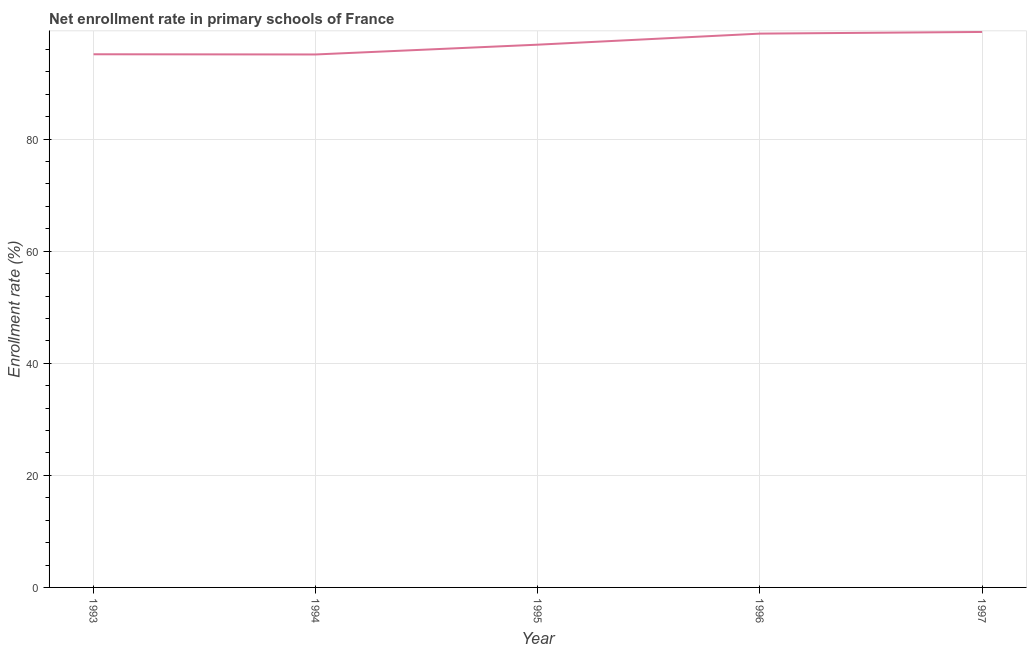What is the net enrollment rate in primary schools in 1997?
Provide a succinct answer. 99.12. Across all years, what is the maximum net enrollment rate in primary schools?
Give a very brief answer. 99.12. Across all years, what is the minimum net enrollment rate in primary schools?
Ensure brevity in your answer.  95.11. In which year was the net enrollment rate in primary schools minimum?
Ensure brevity in your answer.  1994. What is the sum of the net enrollment rate in primary schools?
Ensure brevity in your answer.  485.06. What is the difference between the net enrollment rate in primary schools in 1994 and 1995?
Make the answer very short. -1.75. What is the average net enrollment rate in primary schools per year?
Your answer should be very brief. 97.01. What is the median net enrollment rate in primary schools?
Your response must be concise. 96.86. In how many years, is the net enrollment rate in primary schools greater than 44 %?
Your answer should be very brief. 5. Do a majority of the years between 1993 and 1997 (inclusive) have net enrollment rate in primary schools greater than 80 %?
Provide a succinct answer. Yes. What is the ratio of the net enrollment rate in primary schools in 1993 to that in 1994?
Offer a terse response. 1. Is the net enrollment rate in primary schools in 1993 less than that in 1996?
Give a very brief answer. Yes. Is the difference between the net enrollment rate in primary schools in 1995 and 1997 greater than the difference between any two years?
Offer a very short reply. No. What is the difference between the highest and the second highest net enrollment rate in primary schools?
Your response must be concise. 0.3. Is the sum of the net enrollment rate in primary schools in 1994 and 1997 greater than the maximum net enrollment rate in primary schools across all years?
Provide a short and direct response. Yes. What is the difference between the highest and the lowest net enrollment rate in primary schools?
Offer a very short reply. 4.02. What is the difference between two consecutive major ticks on the Y-axis?
Keep it short and to the point. 20. What is the title of the graph?
Keep it short and to the point. Net enrollment rate in primary schools of France. What is the label or title of the Y-axis?
Offer a very short reply. Enrollment rate (%). What is the Enrollment rate (%) in 1993?
Ensure brevity in your answer.  95.14. What is the Enrollment rate (%) in 1994?
Offer a terse response. 95.11. What is the Enrollment rate (%) in 1995?
Your response must be concise. 96.86. What is the Enrollment rate (%) of 1996?
Ensure brevity in your answer.  98.83. What is the Enrollment rate (%) of 1997?
Your response must be concise. 99.12. What is the difference between the Enrollment rate (%) in 1993 and 1994?
Offer a very short reply. 0.03. What is the difference between the Enrollment rate (%) in 1993 and 1995?
Your answer should be very brief. -1.71. What is the difference between the Enrollment rate (%) in 1993 and 1996?
Ensure brevity in your answer.  -3.69. What is the difference between the Enrollment rate (%) in 1993 and 1997?
Offer a very short reply. -3.98. What is the difference between the Enrollment rate (%) in 1994 and 1995?
Ensure brevity in your answer.  -1.75. What is the difference between the Enrollment rate (%) in 1994 and 1996?
Ensure brevity in your answer.  -3.72. What is the difference between the Enrollment rate (%) in 1994 and 1997?
Offer a terse response. -4.02. What is the difference between the Enrollment rate (%) in 1995 and 1996?
Offer a very short reply. -1.97. What is the difference between the Enrollment rate (%) in 1995 and 1997?
Make the answer very short. -2.27. What is the difference between the Enrollment rate (%) in 1996 and 1997?
Your answer should be very brief. -0.3. What is the ratio of the Enrollment rate (%) in 1993 to that in 1996?
Your response must be concise. 0.96. What is the ratio of the Enrollment rate (%) in 1994 to that in 1997?
Offer a very short reply. 0.96. What is the ratio of the Enrollment rate (%) in 1995 to that in 1997?
Keep it short and to the point. 0.98. 